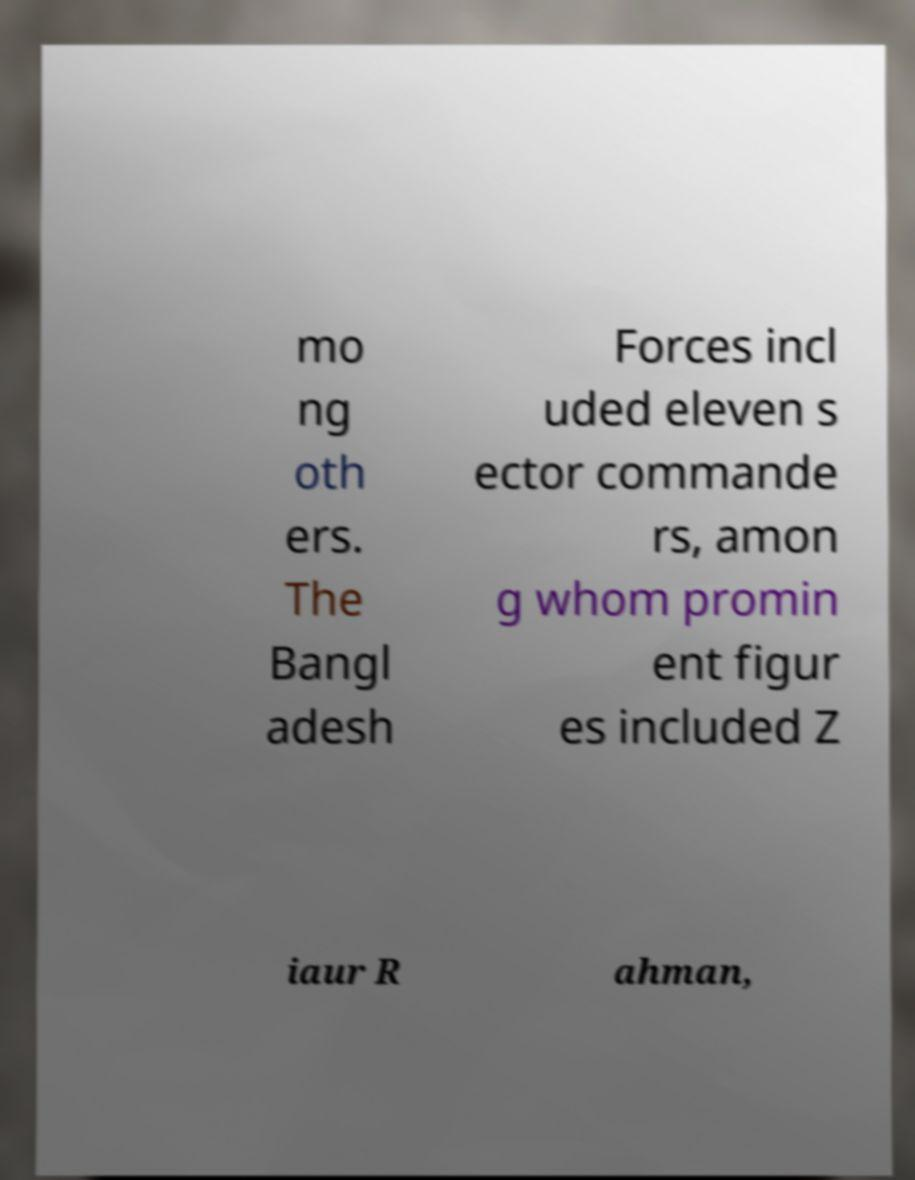For documentation purposes, I need the text within this image transcribed. Could you provide that? mo ng oth ers. The Bangl adesh Forces incl uded eleven s ector commande rs, amon g whom promin ent figur es included Z iaur R ahman, 